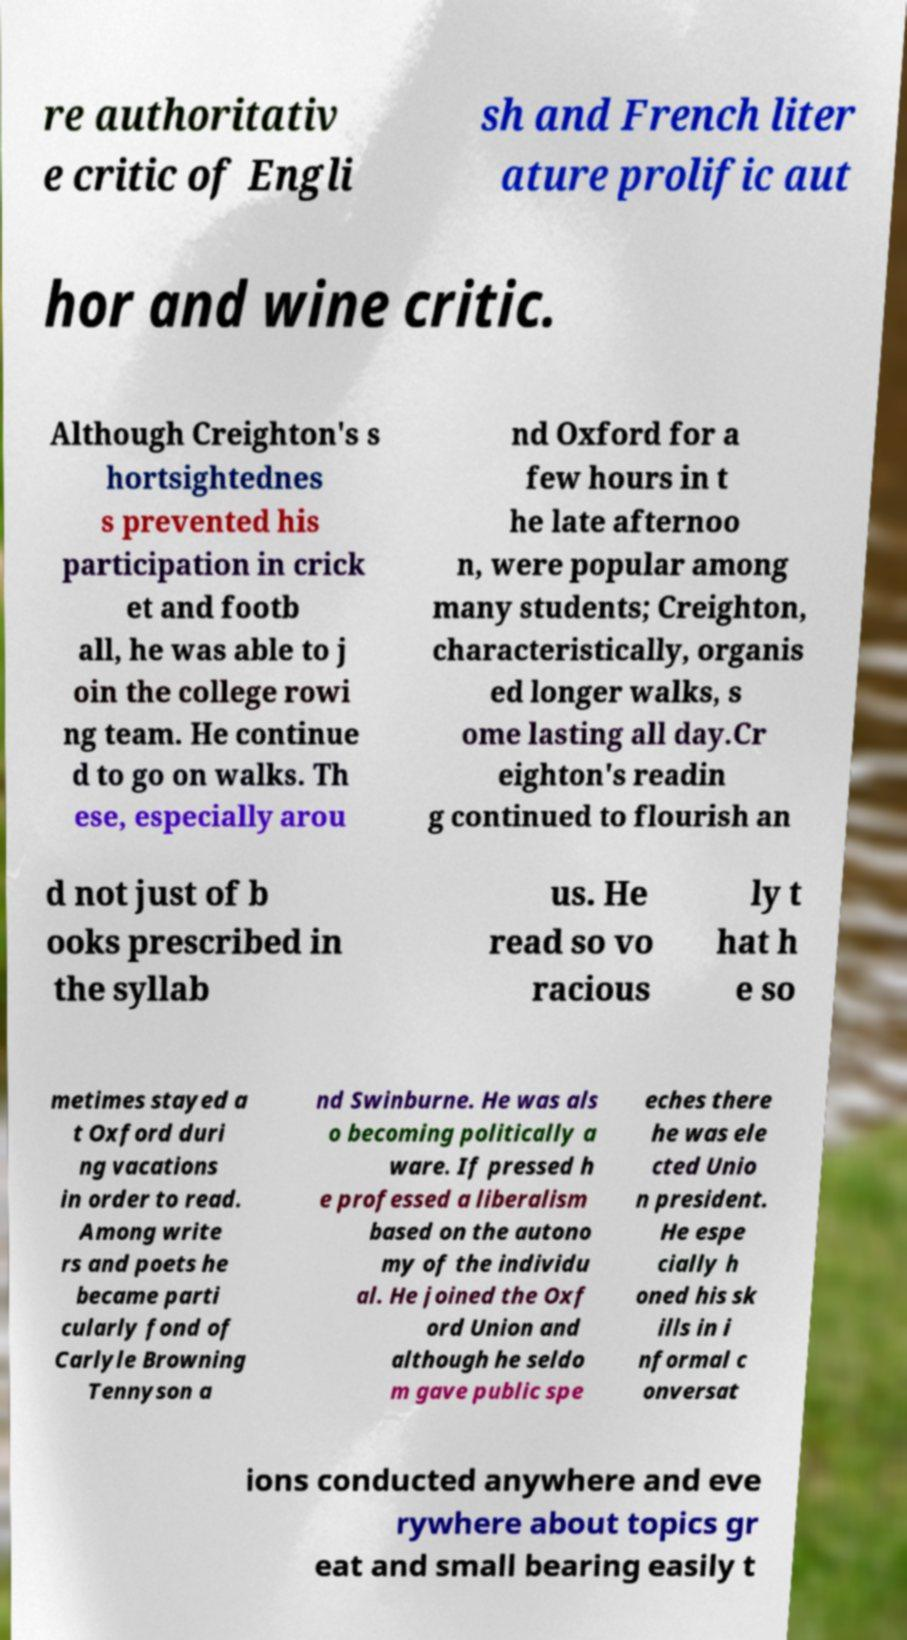Please read and relay the text visible in this image. What does it say? re authoritativ e critic of Engli sh and French liter ature prolific aut hor and wine critic. Although Creighton's s hortsightednes s prevented his participation in crick et and footb all, he was able to j oin the college rowi ng team. He continue d to go on walks. Th ese, especially arou nd Oxford for a few hours in t he late afternoo n, were popular among many students; Creighton, characteristically, organis ed longer walks, s ome lasting all day.Cr eighton's readin g continued to flourish an d not just of b ooks prescribed in the syllab us. He read so vo racious ly t hat h e so metimes stayed a t Oxford duri ng vacations in order to read. Among write rs and poets he became parti cularly fond of Carlyle Browning Tennyson a nd Swinburne. He was als o becoming politically a ware. If pressed h e professed a liberalism based on the autono my of the individu al. He joined the Oxf ord Union and although he seldo m gave public spe eches there he was ele cted Unio n president. He espe cially h oned his sk ills in i nformal c onversat ions conducted anywhere and eve rywhere about topics gr eat and small bearing easily t 